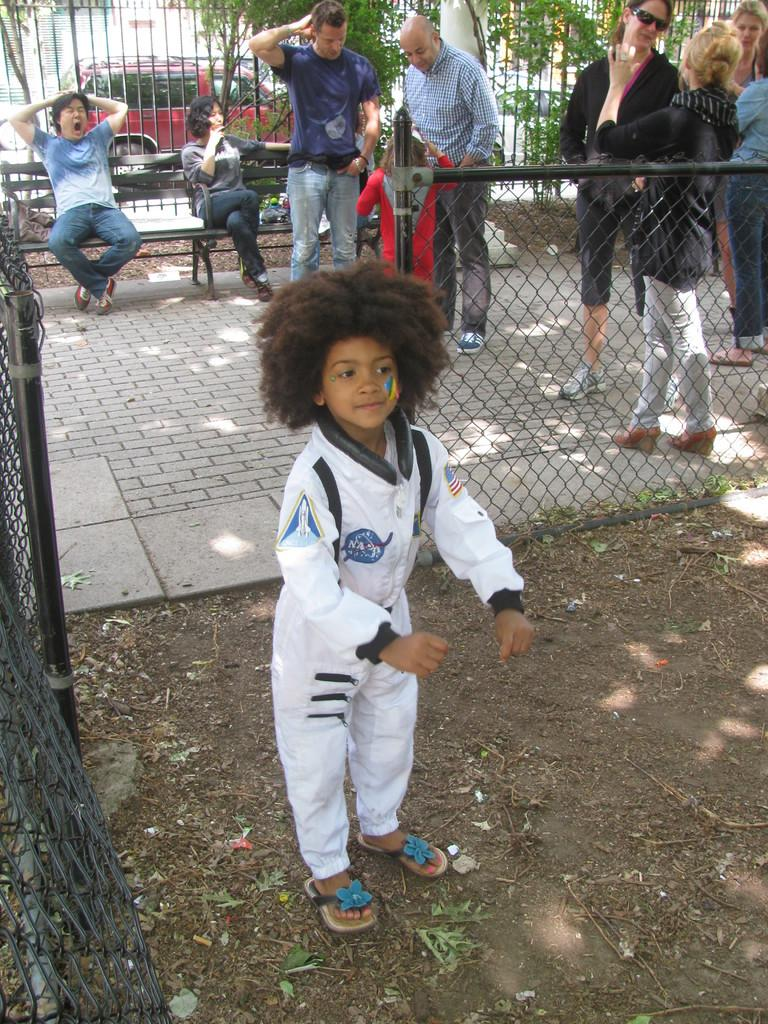How many people are sitting on the bench in the image? There are two people sitting on a bench in the image. What are the people standing on in the image? The people standing are on the ground. What type of barrier can be seen in the image? There are fences in the image. What type of vegetation is present in the image? There are trees in the image. What can be seen in the distance in the image? Vehicles are visible in the background of the image. Is there a balloon floating in the sky in the image? No, there is no balloon visible in the sky in the image. 